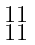<formula> <loc_0><loc_0><loc_500><loc_500>\begin{smallmatrix} 1 1 \\ 1 1 \end{smallmatrix}</formula> 